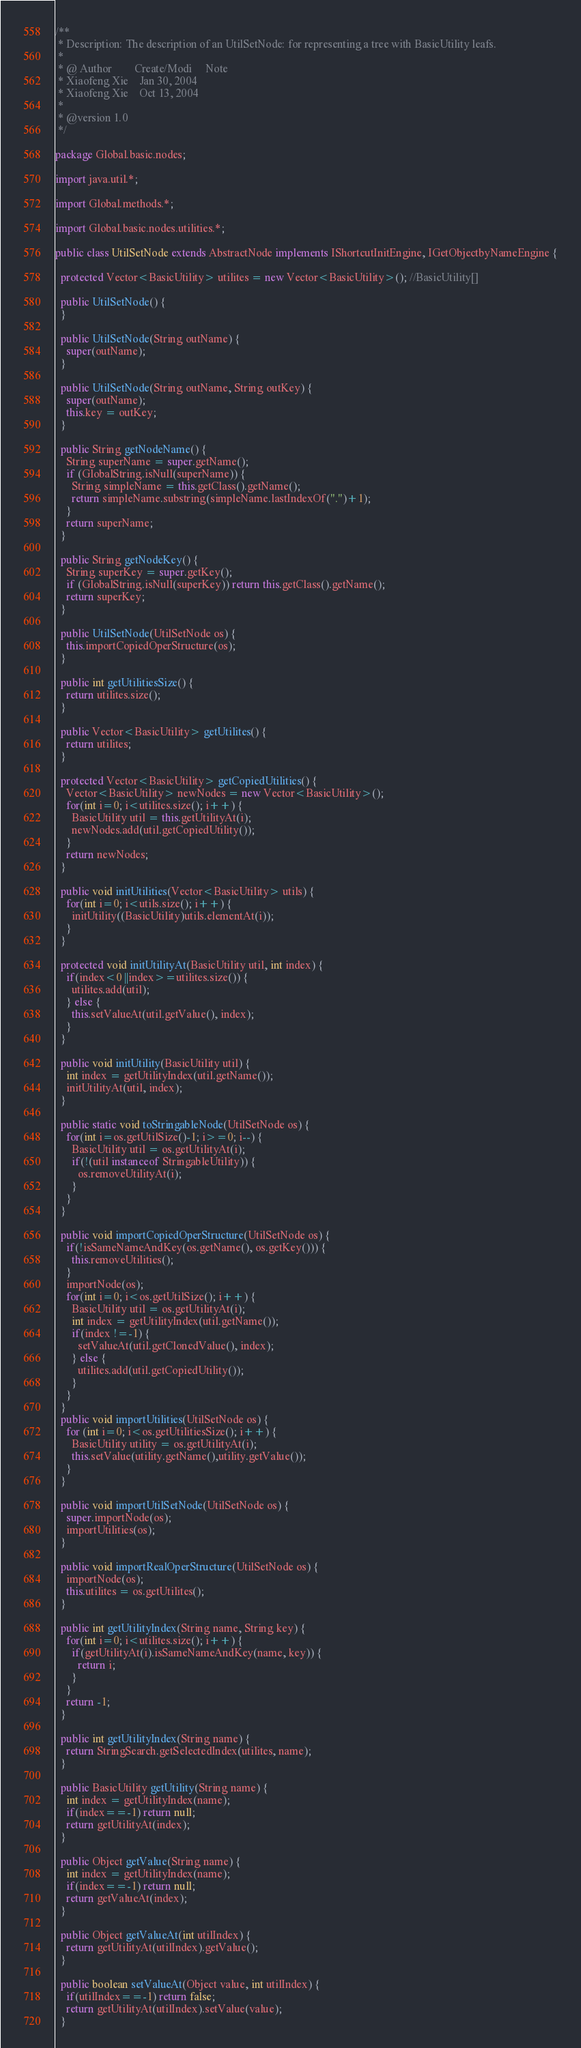<code> <loc_0><loc_0><loc_500><loc_500><_Java_>/**
 * Description: The description of an UtilSetNode: for representing a tree with BasicUtility leafs.
 *
 * @ Author        Create/Modi     Note
 * Xiaofeng Xie    Jan 30, 2004
 * Xiaofeng Xie    Oct 13, 2004
 *
 * @version 1.0
 */

package Global.basic.nodes;

import java.util.*;

import Global.methods.*;

import Global.basic.nodes.utilities.*;

public class UtilSetNode extends AbstractNode implements IShortcutInitEngine, IGetObjectbyNameEngine {

  protected Vector<BasicUtility> utilites = new Vector<BasicUtility>(); //BasicUtility[]

  public UtilSetNode() {
  }

  public UtilSetNode(String outName) {
    super(outName);
  }

  public UtilSetNode(String outName, String outKey) {
    super(outName);
    this.key = outKey;
  }

  public String getNodeName() {
    String superName = super.getName();
    if (GlobalString.isNull(superName)) {
      String simpleName = this.getClass().getName();
      return simpleName.substring(simpleName.lastIndexOf(".")+1);
    }
    return superName;
  }

  public String getNodeKey() {
    String superKey = super.getKey();
    if (GlobalString.isNull(superKey)) return this.getClass().getName();
    return superKey;
  }

  public UtilSetNode(UtilSetNode os) {
    this.importCopiedOperStructure(os);
  }

  public int getUtilitiesSize() {
    return utilites.size();
  }

  public Vector<BasicUtility> getUtilites() {
    return utilites;
  }

  protected Vector<BasicUtility> getCopiedUtilities() {
    Vector<BasicUtility> newNodes = new Vector<BasicUtility>();
    for(int i=0; i<utilites.size(); i++) {
      BasicUtility util = this.getUtilityAt(i);
      newNodes.add(util.getCopiedUtility());
    }
    return newNodes;
  }

  public void initUtilities(Vector<BasicUtility> utils) {
    for(int i=0; i<utils.size(); i++) {
      initUtility((BasicUtility)utils.elementAt(i));
    }
  }

  protected void initUtilityAt(BasicUtility util, int index) {
    if(index<0 ||index>=utilites.size()) {
      utilites.add(util);
    } else {
      this.setValueAt(util.getValue(), index);
    }
  }

  public void initUtility(BasicUtility util) {
    int index = getUtilityIndex(util.getName());
    initUtilityAt(util, index);
  }

  public static void toStringableNode(UtilSetNode os) {
    for(int i=os.getUtilSize()-1; i>=0; i--) {
      BasicUtility util = os.getUtilityAt(i);
      if(!(util instanceof StringableUtility)) {
        os.removeUtilityAt(i);
      }
    }
  }

  public void importCopiedOperStructure(UtilSetNode os) {
    if(!isSameNameAndKey(os.getName(), os.getKey())) {
      this.removeUtilities();
    }
    importNode(os);
    for(int i=0; i<os.getUtilSize(); i++) {
      BasicUtility util = os.getUtilityAt(i);
      int index = getUtilityIndex(util.getName());
      if(index !=-1) {
        setValueAt(util.getClonedValue(), index);
      } else {
        utilites.add(util.getCopiedUtility());
      }
    }
  }
  public void importUtilities(UtilSetNode os) {
    for (int i=0; i<os.getUtilitiesSize(); i++) {
      BasicUtility utility = os.getUtilityAt(i);
      this.setValue(utility.getName(),utility.getValue());
    }
  }

  public void importUtilSetNode(UtilSetNode os) {
    super.importNode(os);
    importUtilities(os);
  }

  public void importRealOperStructure(UtilSetNode os) {
    importNode(os);
    this.utilites = os.getUtilites();
  }

  public int getUtilityIndex(String name, String key) {
    for(int i=0; i<utilites.size(); i++) {
      if(getUtilityAt(i).isSameNameAndKey(name, key)) {
        return i;
      }
    }
    return -1;
  }

  public int getUtilityIndex(String name) {
    return StringSearch.getSelectedIndex(utilites, name);
  }

  public BasicUtility getUtility(String name) {
    int index = getUtilityIndex(name);
    if(index==-1) return null;
    return getUtilityAt(index);
  }

  public Object getValue(String name) {
    int index = getUtilityIndex(name);
    if(index==-1) return null;
    return getValueAt(index);
  }

  public Object getValueAt(int utilIndex) {
    return getUtilityAt(utilIndex).getValue();
  }

  public boolean setValueAt(Object value, int utilIndex) {
    if(utilIndex==-1) return false;
    return getUtilityAt(utilIndex).setValue(value);
  }
</code> 